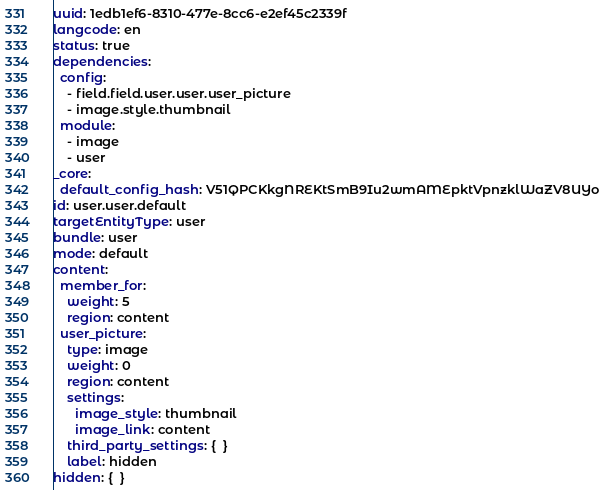<code> <loc_0><loc_0><loc_500><loc_500><_YAML_>uuid: 1edb1ef6-8310-477e-8cc6-e2ef45c2339f
langcode: en
status: true
dependencies:
  config:
    - field.field.user.user.user_picture
    - image.style.thumbnail
  module:
    - image
    - user
_core:
  default_config_hash: V51QPCKkgNREKtSmB9Iu2wmAMEpktVpnzklWaZV8UYo
id: user.user.default
targetEntityType: user
bundle: user
mode: default
content:
  member_for:
    weight: 5
    region: content
  user_picture:
    type: image
    weight: 0
    region: content
    settings:
      image_style: thumbnail
      image_link: content
    third_party_settings: {  }
    label: hidden
hidden: {  }
</code> 